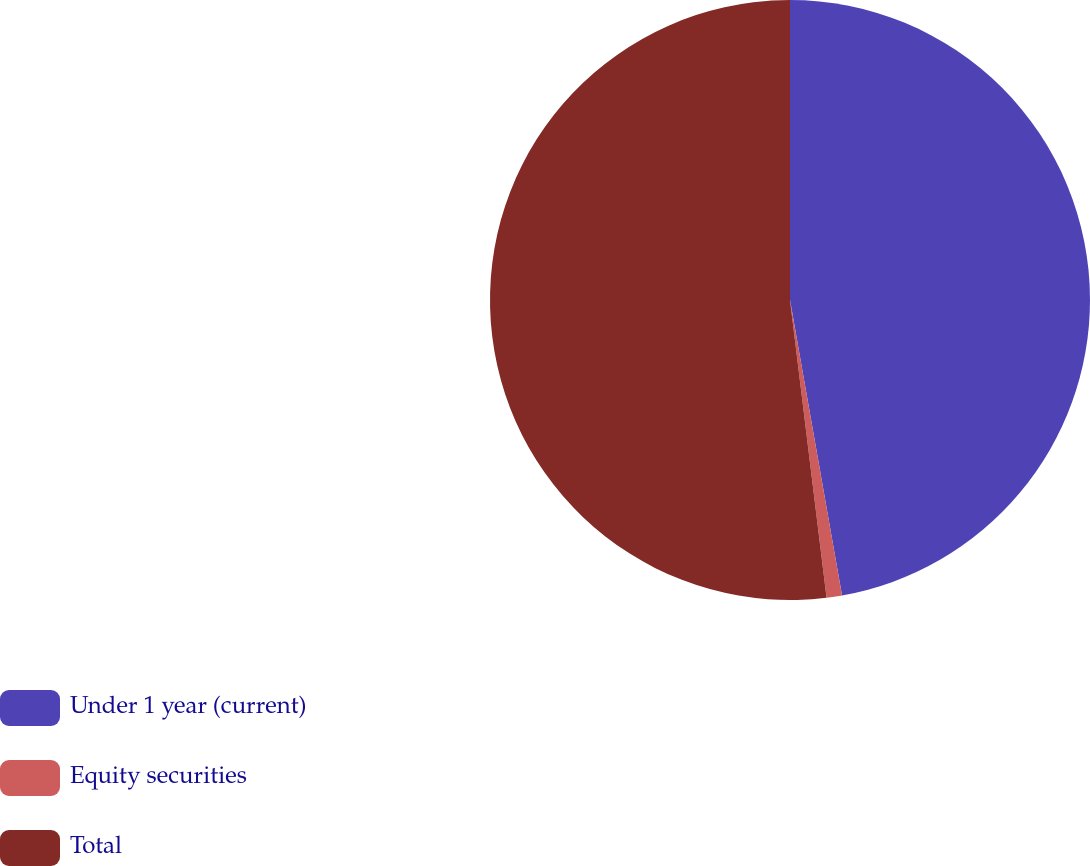<chart> <loc_0><loc_0><loc_500><loc_500><pie_chart><fcel>Under 1 year (current)<fcel>Equity securities<fcel>Total<nl><fcel>47.23%<fcel>0.83%<fcel>51.95%<nl></chart> 